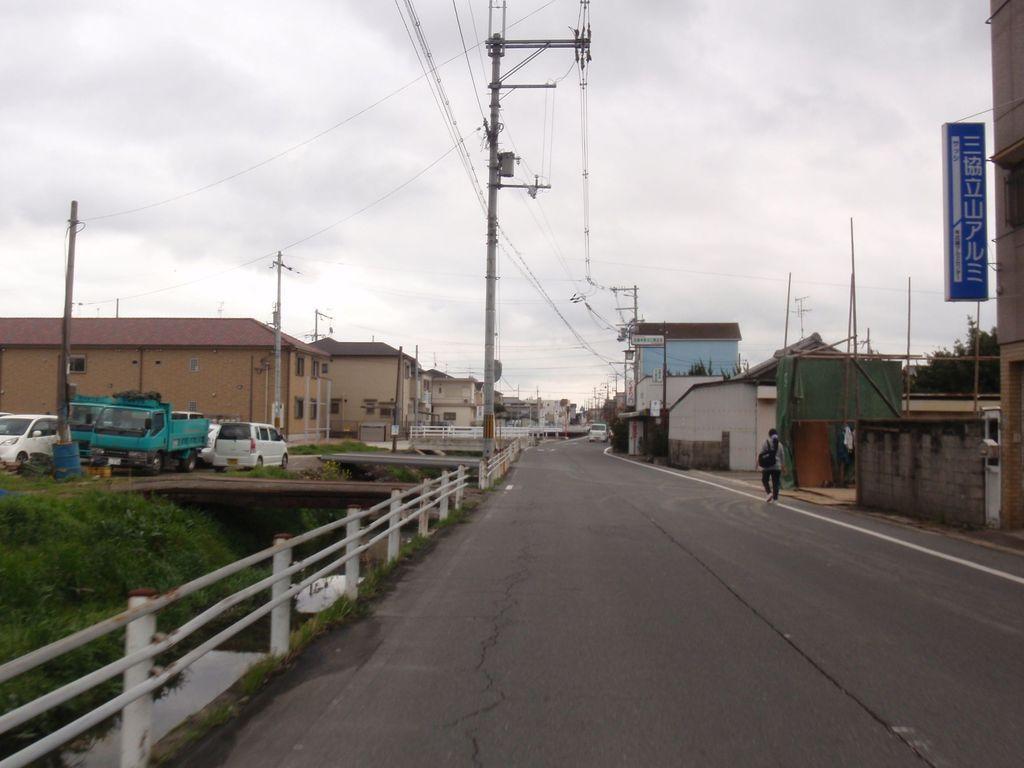Could you give a brief overview of what you see in this image? In this image we can see a person is walking on the road. On the left side we can see fences, grass, plants, vehicles. In the background we can see trees, buildings, windows, poles, wires, boards on the poles and clouds in the sky. 